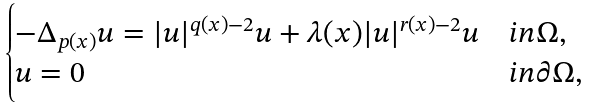<formula> <loc_0><loc_0><loc_500><loc_500>\begin{cases} - \Delta _ { p ( x ) } u = | u | ^ { q ( x ) - 2 } u + \lambda ( x ) | u | ^ { r ( x ) - 2 } u & i n \Omega , \\ u = 0 & i n \partial \Omega , \end{cases}</formula> 